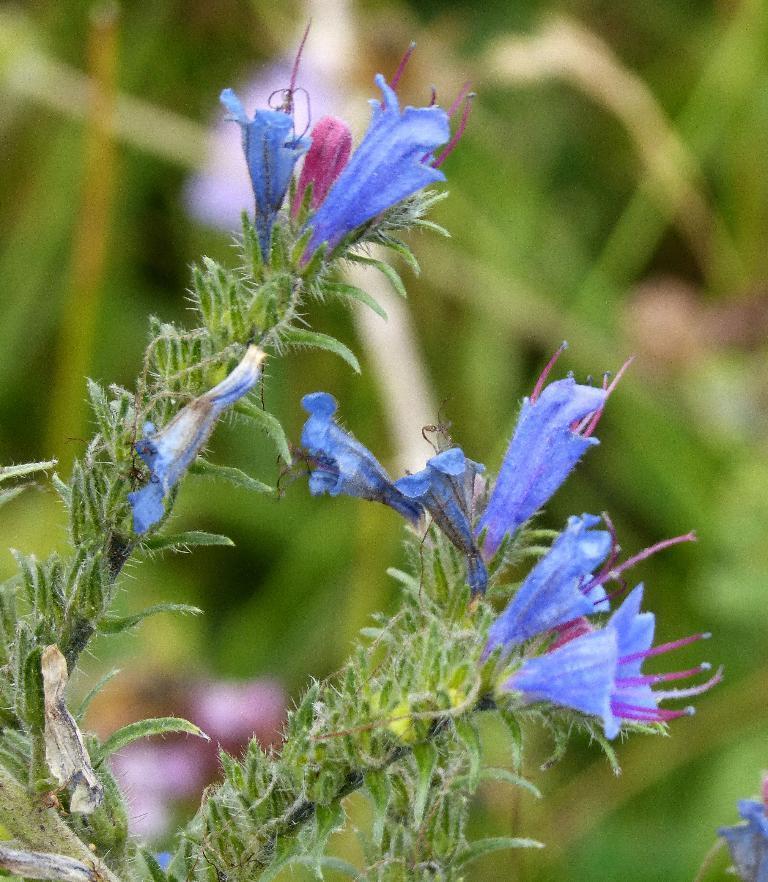Describe this image in one or two sentences. In the picture I can see flower plants. These flowers are blue in color. The background of the image is blurred. 